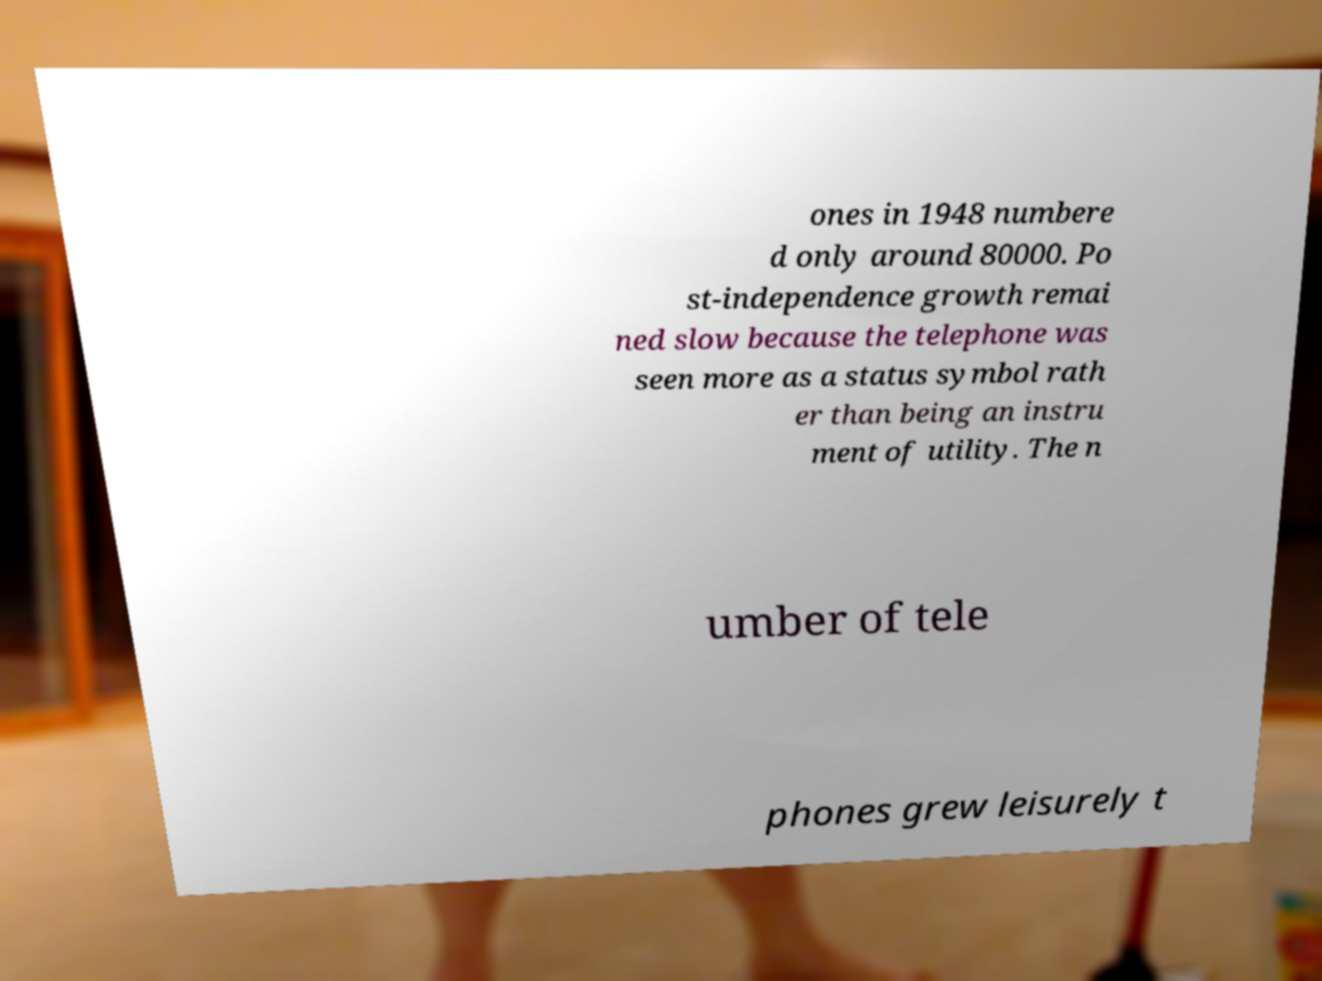Could you assist in decoding the text presented in this image and type it out clearly? ones in 1948 numbere d only around 80000. Po st-independence growth remai ned slow because the telephone was seen more as a status symbol rath er than being an instru ment of utility. The n umber of tele phones grew leisurely t 